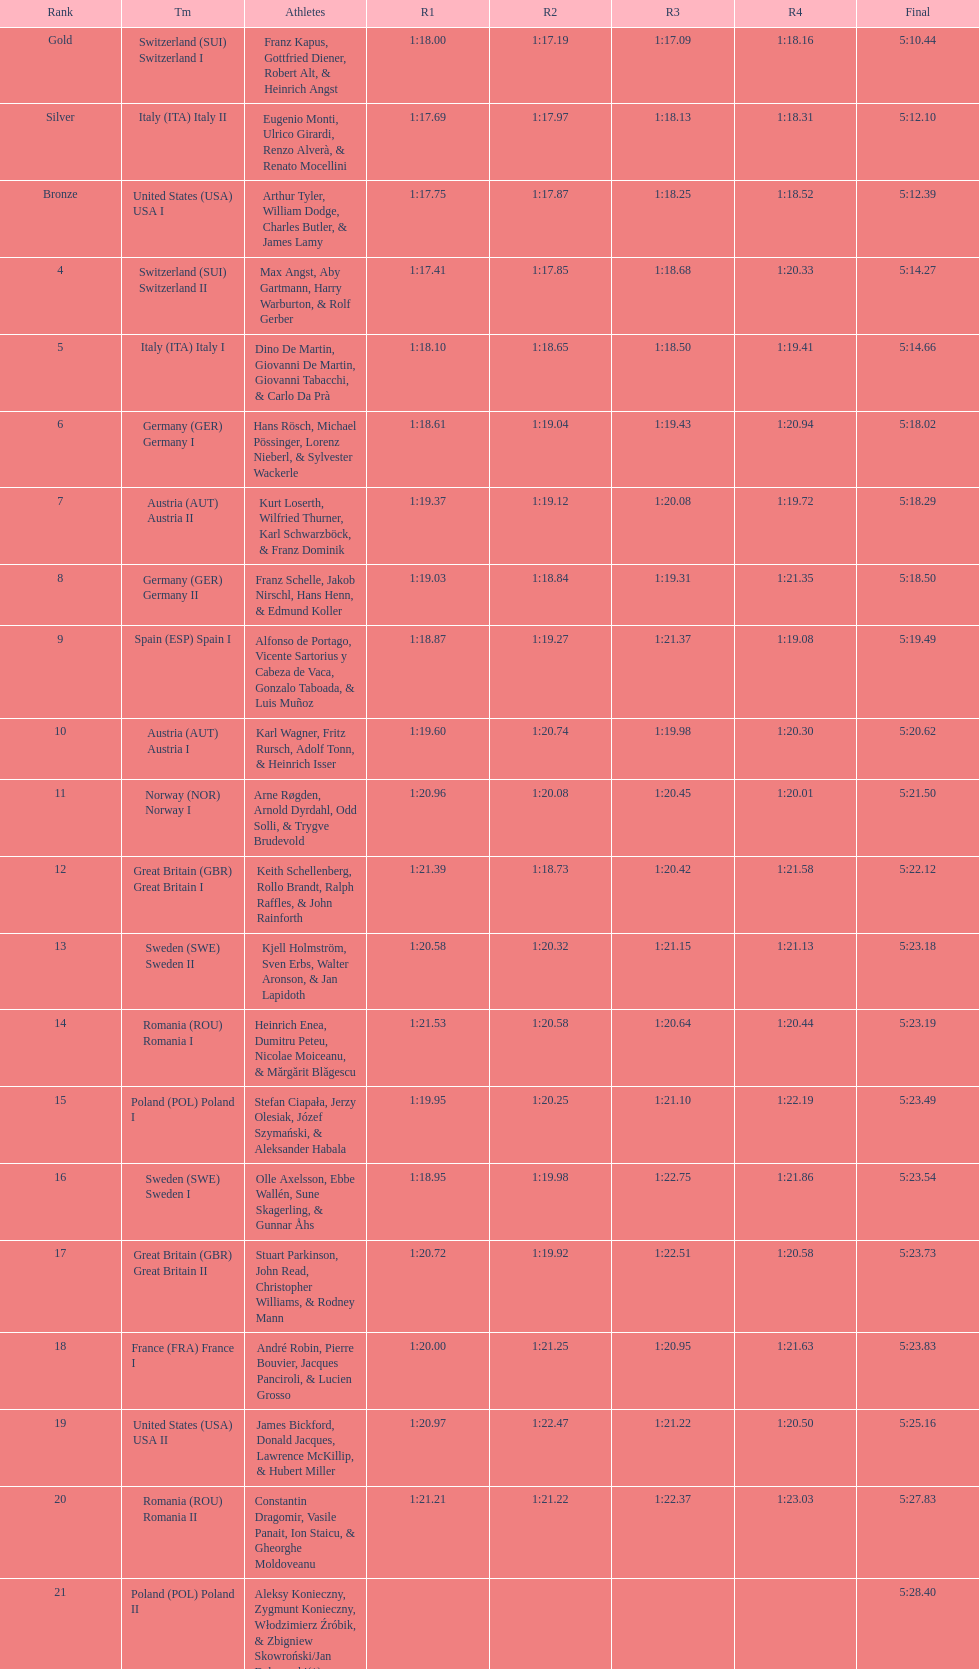Who placed the highest, italy or germany? Italy. 